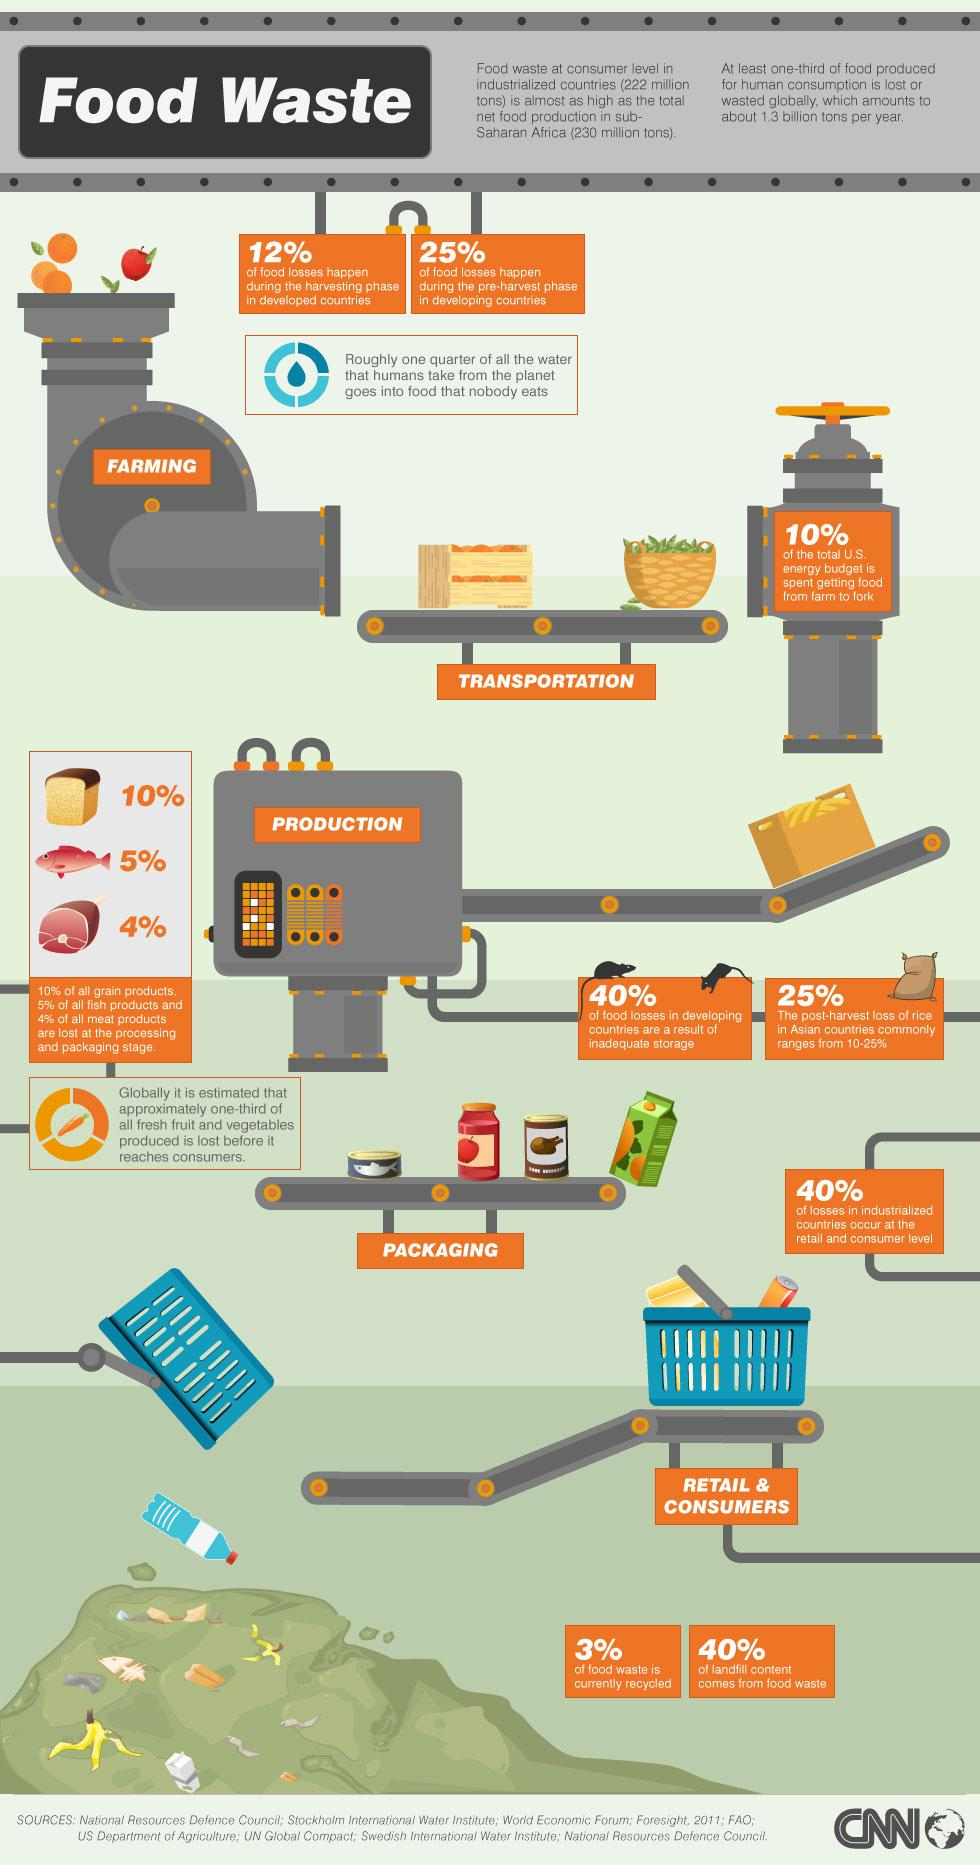Point out several critical features in this image. According to research, 60% of food losses in developing countries are not due to inadequate storage. According to recent studies, 77% of food waste in developing countries is not currently being recycled. In developed countries, only 12% of food losses occur during the harvesting phase, according to recent studies. In developing countries, only 40% of landfill content comes from food waste. 